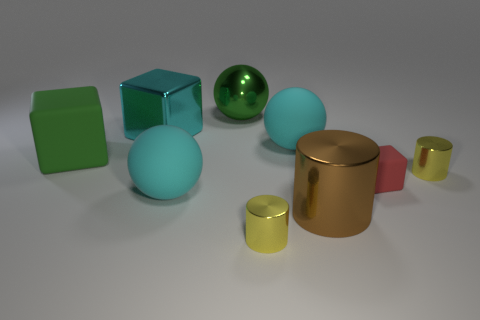What number of other objects are there of the same material as the large cylinder?
Your answer should be very brief. 4. How many things are big cyan shiny objects or large metal things in front of the large cyan metal block?
Keep it short and to the point. 2. Is the number of cyan balls less than the number of small red balls?
Provide a succinct answer. No. What is the color of the rubber block that is behind the tiny cylinder on the right side of the large matte object that is right of the big green metal thing?
Offer a terse response. Green. Is the material of the green block the same as the big green sphere?
Give a very brief answer. No. How many cubes are to the right of the large green rubber object?
Ensure brevity in your answer.  2. There is a green rubber thing that is the same shape as the cyan shiny thing; what is its size?
Make the answer very short. Large. How many brown objects are small metallic cylinders or balls?
Give a very brief answer. 0. What number of tiny yellow metal objects are behind the large block that is left of the cyan cube?
Provide a short and direct response. 0. What number of other objects are the same shape as the green metal thing?
Ensure brevity in your answer.  2. 